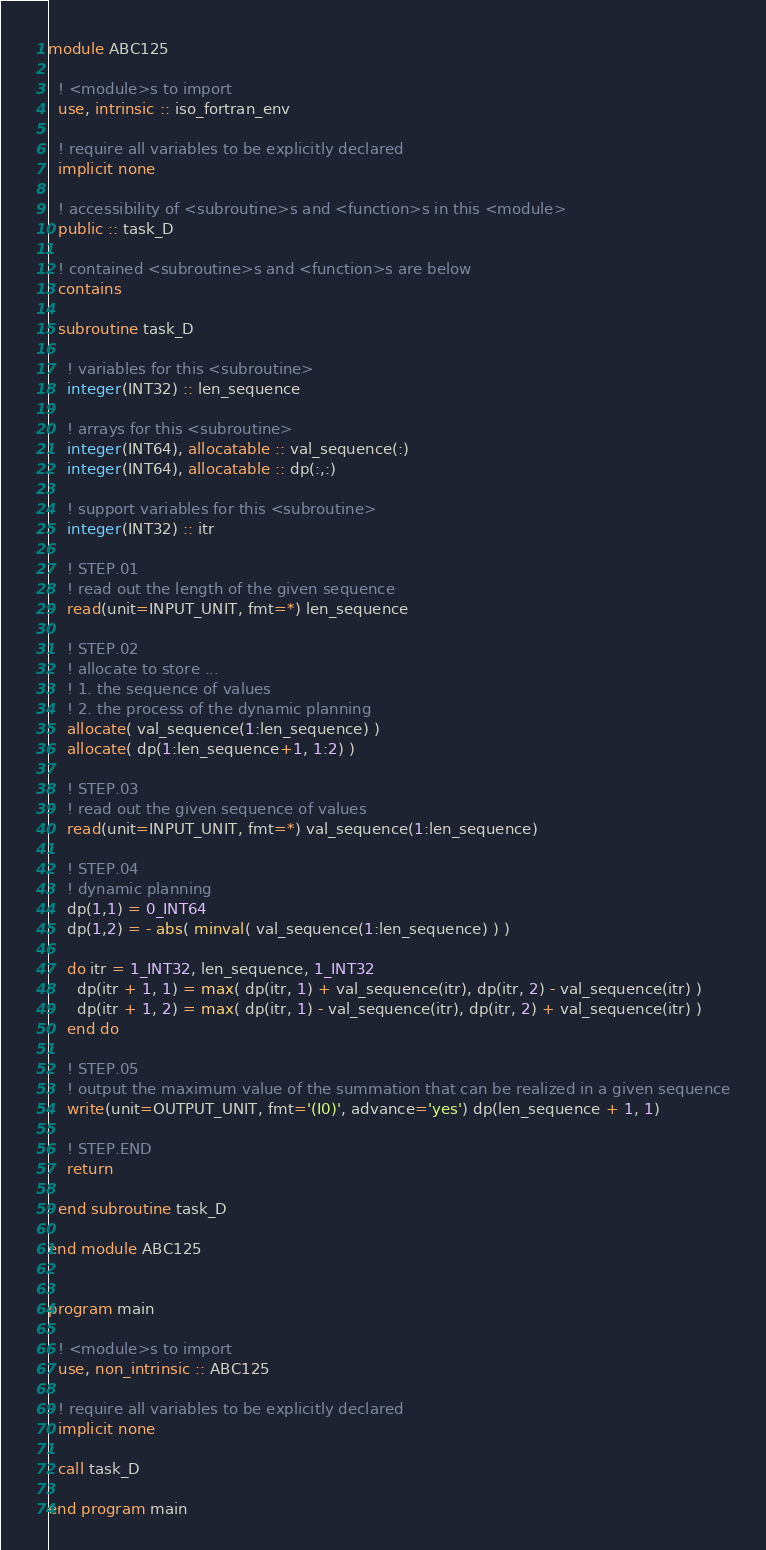Convert code to text. <code><loc_0><loc_0><loc_500><loc_500><_FORTRAN_>module ABC125

  ! <module>s to import
  use, intrinsic :: iso_fortran_env

  ! require all variables to be explicitly declared
  implicit none

  ! accessibility of <subroutine>s and <function>s in this <module>
  public :: task_D

  ! contained <subroutine>s and <function>s are below
  contains

  subroutine task_D

    ! variables for this <subroutine>
    integer(INT32) :: len_sequence
    
    ! arrays for this <subroutine>
    integer(INT64), allocatable :: val_sequence(:)
    integer(INT64), allocatable :: dp(:,:)

    ! support variables for this <subroutine>
    integer(INT32) :: itr

    ! STEP.01
    ! read out the length of the given sequence
    read(unit=INPUT_UNIT, fmt=*) len_sequence

    ! STEP.02
    ! allocate to store ...
    ! 1. the sequence of values
    ! 2. the process of the dynamic planning
    allocate( val_sequence(1:len_sequence) )
    allocate( dp(1:len_sequence+1, 1:2) )

    ! STEP.03
    ! read out the given sequence of values
    read(unit=INPUT_UNIT, fmt=*) val_sequence(1:len_sequence)

    ! STEP.04
    ! dynamic planning
    dp(1,1) = 0_INT64
    dp(1,2) = - abs( minval( val_sequence(1:len_sequence) ) )

    do itr = 1_INT32, len_sequence, 1_INT32
      dp(itr + 1, 1) = max( dp(itr, 1) + val_sequence(itr), dp(itr, 2) - val_sequence(itr) )
      dp(itr + 1, 2) = max( dp(itr, 1) - val_sequence(itr), dp(itr, 2) + val_sequence(itr) )
    end do

    ! STEP.05
    ! output the maximum value of the summation that can be realized in a given sequence
    write(unit=OUTPUT_UNIT, fmt='(I0)', advance='yes') dp(len_sequence + 1, 1)

    ! STEP.END
    return

  end subroutine task_D

end module ABC125


program main

  ! <module>s to import
  use, non_intrinsic :: ABC125

  ! require all variables to be explicitly declared
  implicit none

  call task_D

end program main</code> 